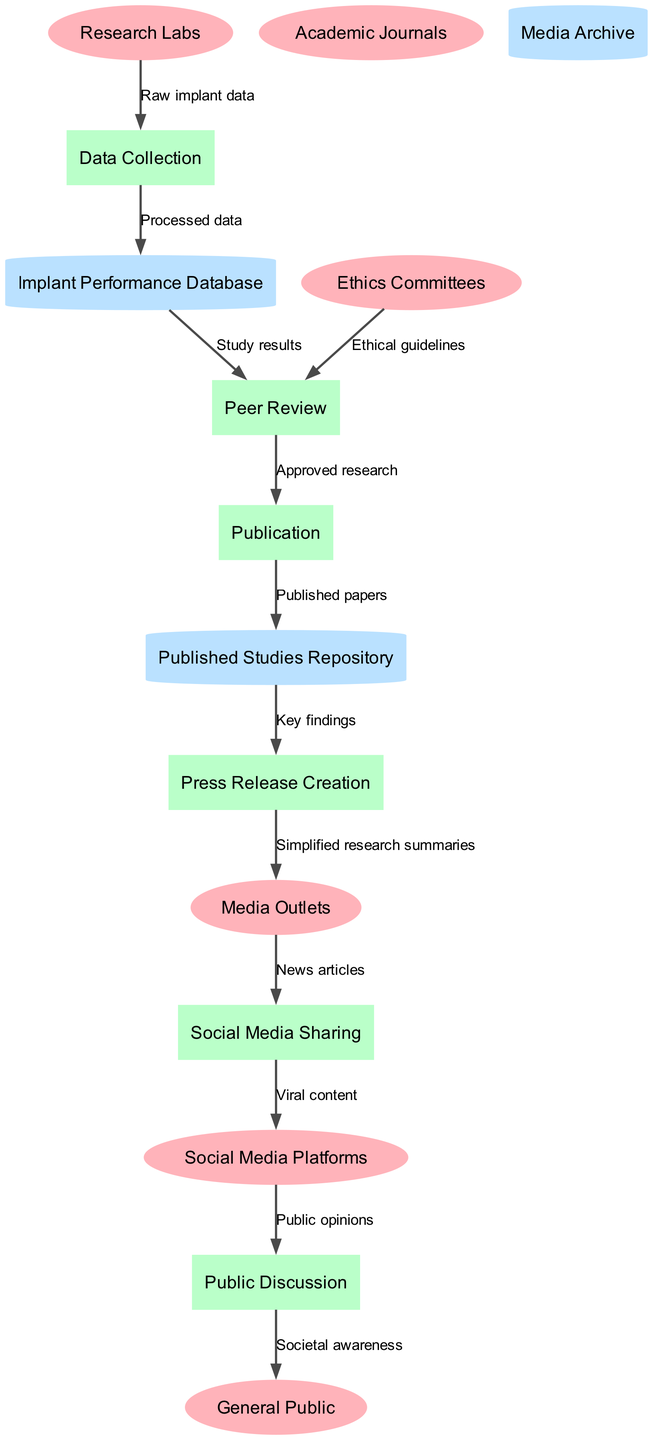What are the external entities in the diagram? The external entities are listed under a specific section in the diagram. They include Research Labs, Ethics Committees, Academic Journals, Media Outlets, Social Media Platforms, and General Public.
Answer: Research Labs, Ethics Committees, Academic Journals, Media Outlets, Social Media Platforms, General Public How many processes are depicted in the diagram? The processes are enumerated in a section of the diagram, and upon counting them, there are six distinct processes listed.
Answer: 6 What is the flow of data from Ethics Committees to Peer Review? The flow connects Ethics Committees directly to Peer Review. It is labeled as "Ethical guidelines," indicating the specific data that moves along this flow.
Answer: Ethical guidelines What is the final output in the data flow represented in the diagram? To determine the final output, we trace the data flow from Public Discussion to General Public, suggesting the output is "Societal awareness."
Answer: Societal awareness How do Media Outlets contribute to the social awareness of bionic implants? Media Outlets receive "Simplified research summaries" and produce "News articles," which are then shared on social media platforms, indicating their role in disseminating information to the public.
Answer: News articles 